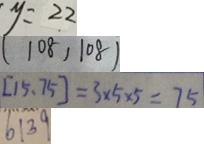Convert formula to latex. <formula><loc_0><loc_0><loc_500><loc_500>y = 2 2 
 ( 1 0 8 , 1 0 \dot { 8 } ) 
 [ 1 5 . 7 5 ] = 3 \times 5 \times 5 = 7 5 
 6 1 3 9</formula> 